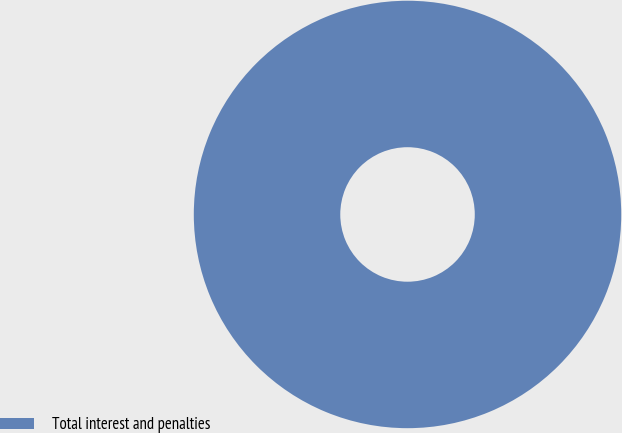<chart> <loc_0><loc_0><loc_500><loc_500><pie_chart><fcel>Total interest and penalties<nl><fcel>100.0%<nl></chart> 